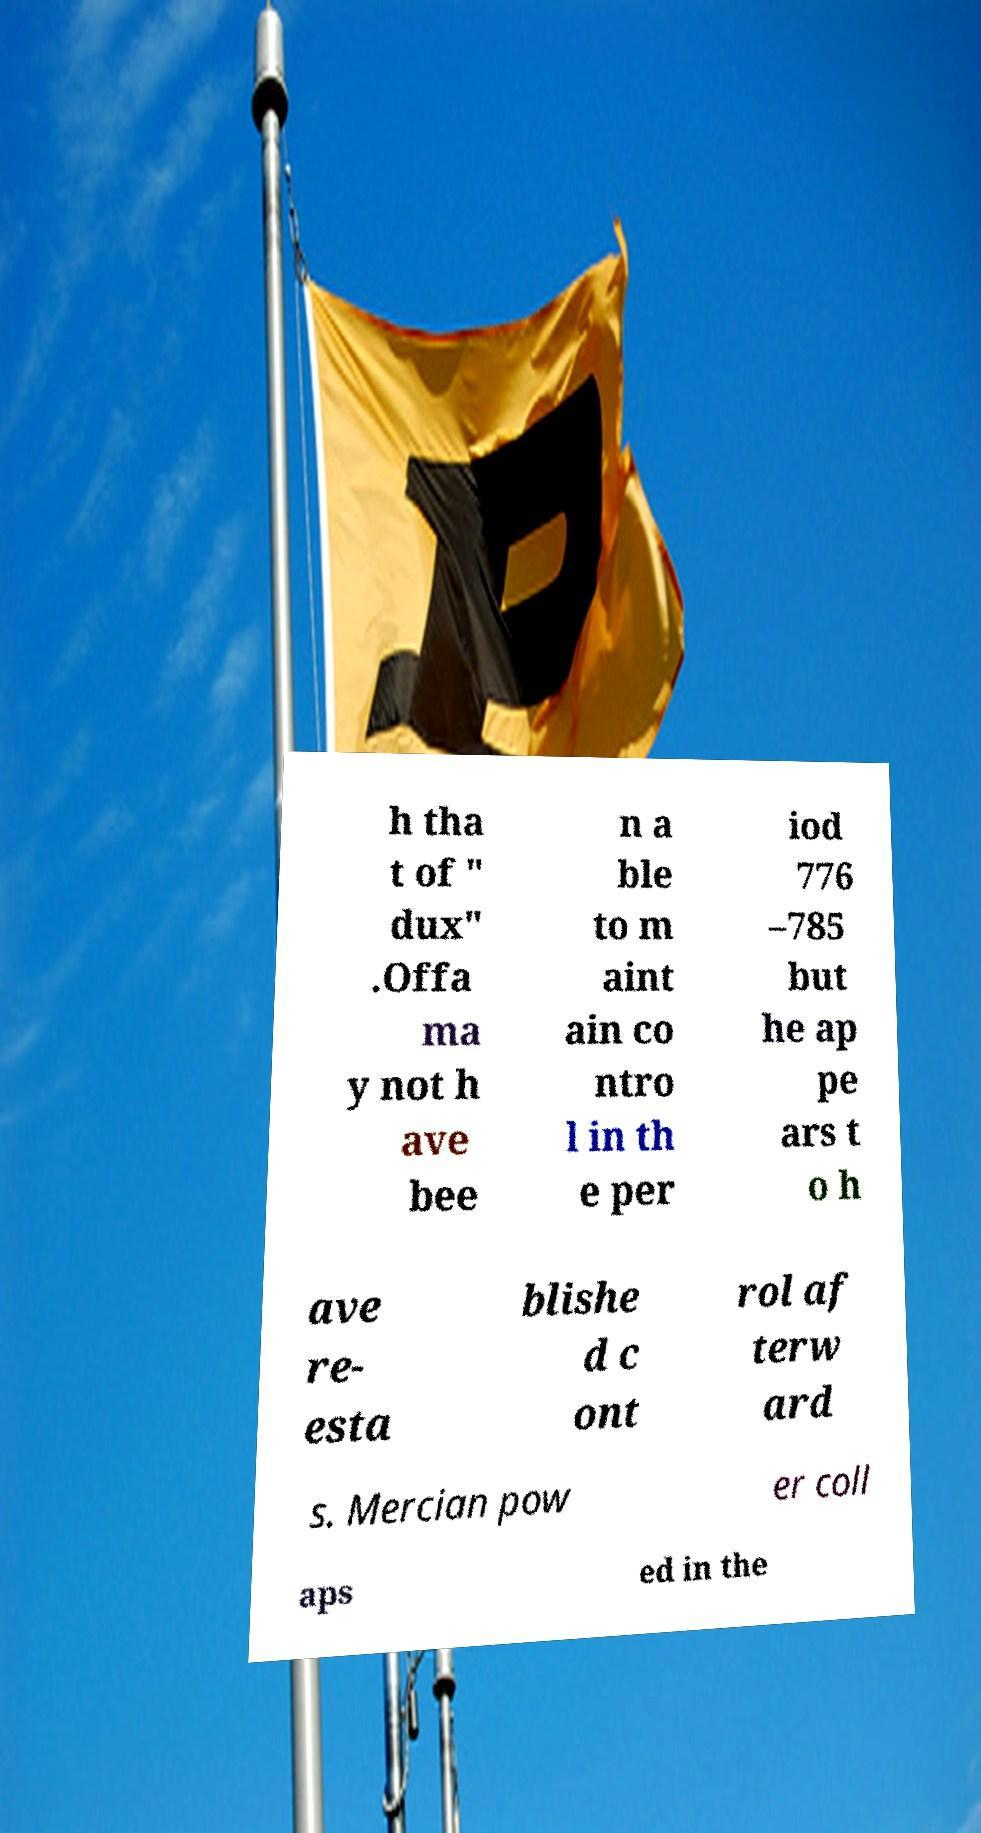I need the written content from this picture converted into text. Can you do that? h tha t of " dux" .Offa ma y not h ave bee n a ble to m aint ain co ntro l in th e per iod 776 –785 but he ap pe ars t o h ave re- esta blishe d c ont rol af terw ard s. Mercian pow er coll aps ed in the 